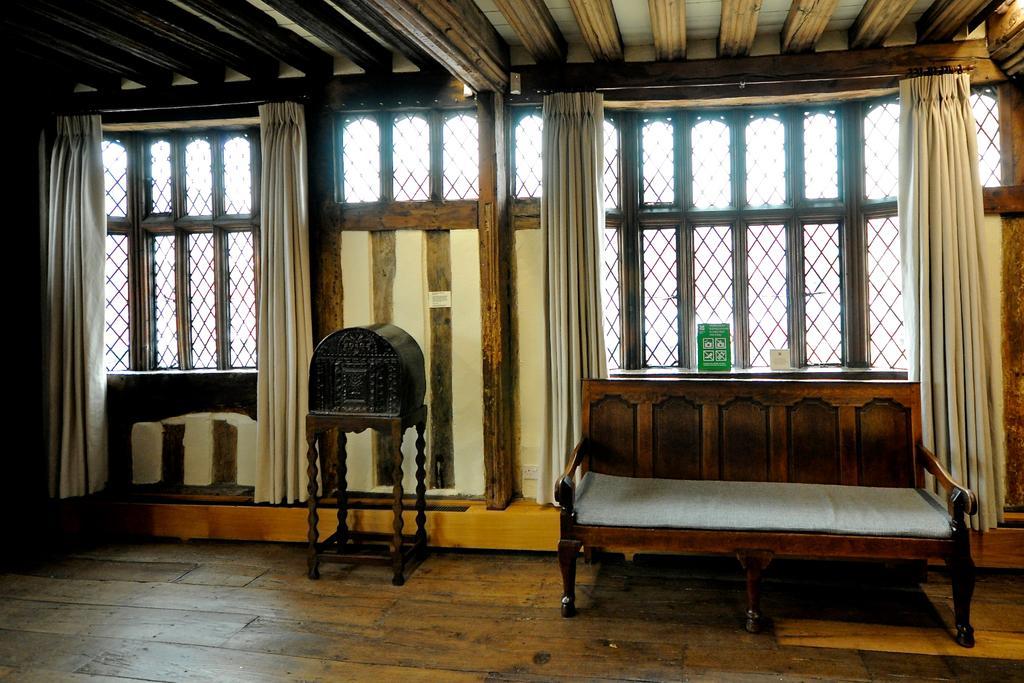In one or two sentences, can you explain what this image depicts? In this image I can see a box in brown color, a wooden couch. Background I few windows, curtains in white color. 